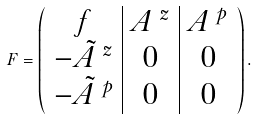<formula> <loc_0><loc_0><loc_500><loc_500>F = \left ( \begin{array} { c | c | c } f & A ^ { \ z } & A ^ { \ p } \\ - \tilde { A } ^ { \ z } & 0 & 0 \\ - \tilde { A } ^ { \ p } & 0 & 0 \end{array} \right ) .</formula> 